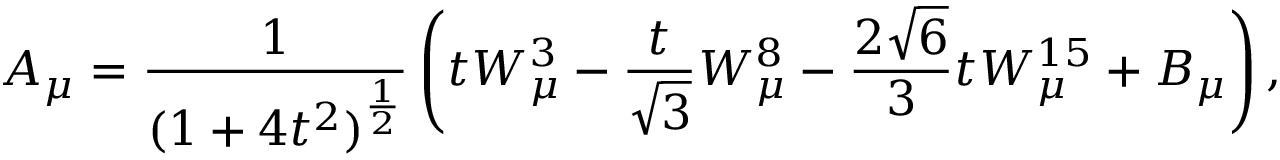<formula> <loc_0><loc_0><loc_500><loc_500>A _ { \mu } = \frac { 1 } { ( 1 + 4 t ^ { 2 } ) ^ { \frac { 1 } { 2 } } } \left ( t W _ { \mu } ^ { 3 } - \frac { t } { \sqrt { 3 } } W _ { \mu } ^ { 8 } - \frac { 2 \sqrt { 6 } } { 3 } t W _ { \mu } ^ { 1 5 } + B _ { \mu } \right ) ,</formula> 